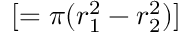Convert formula to latex. <formula><loc_0><loc_0><loc_500><loc_500>[ = \pi ( r _ { 1 } ^ { 2 } - r _ { 2 } ^ { 2 } ) ]</formula> 